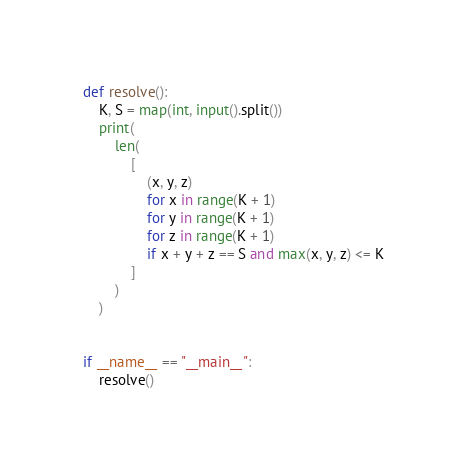<code> <loc_0><loc_0><loc_500><loc_500><_Python_>def resolve():
    K, S = map(int, input().split())
    print(
        len(
            [
                (x, y, z)
                for x in range(K + 1)
                for y in range(K + 1)
                for z in range(K + 1)
                if x + y + z == S and max(x, y, z) <= K
            ]
        )
    )


if __name__ == "__main__":
    resolve()</code> 